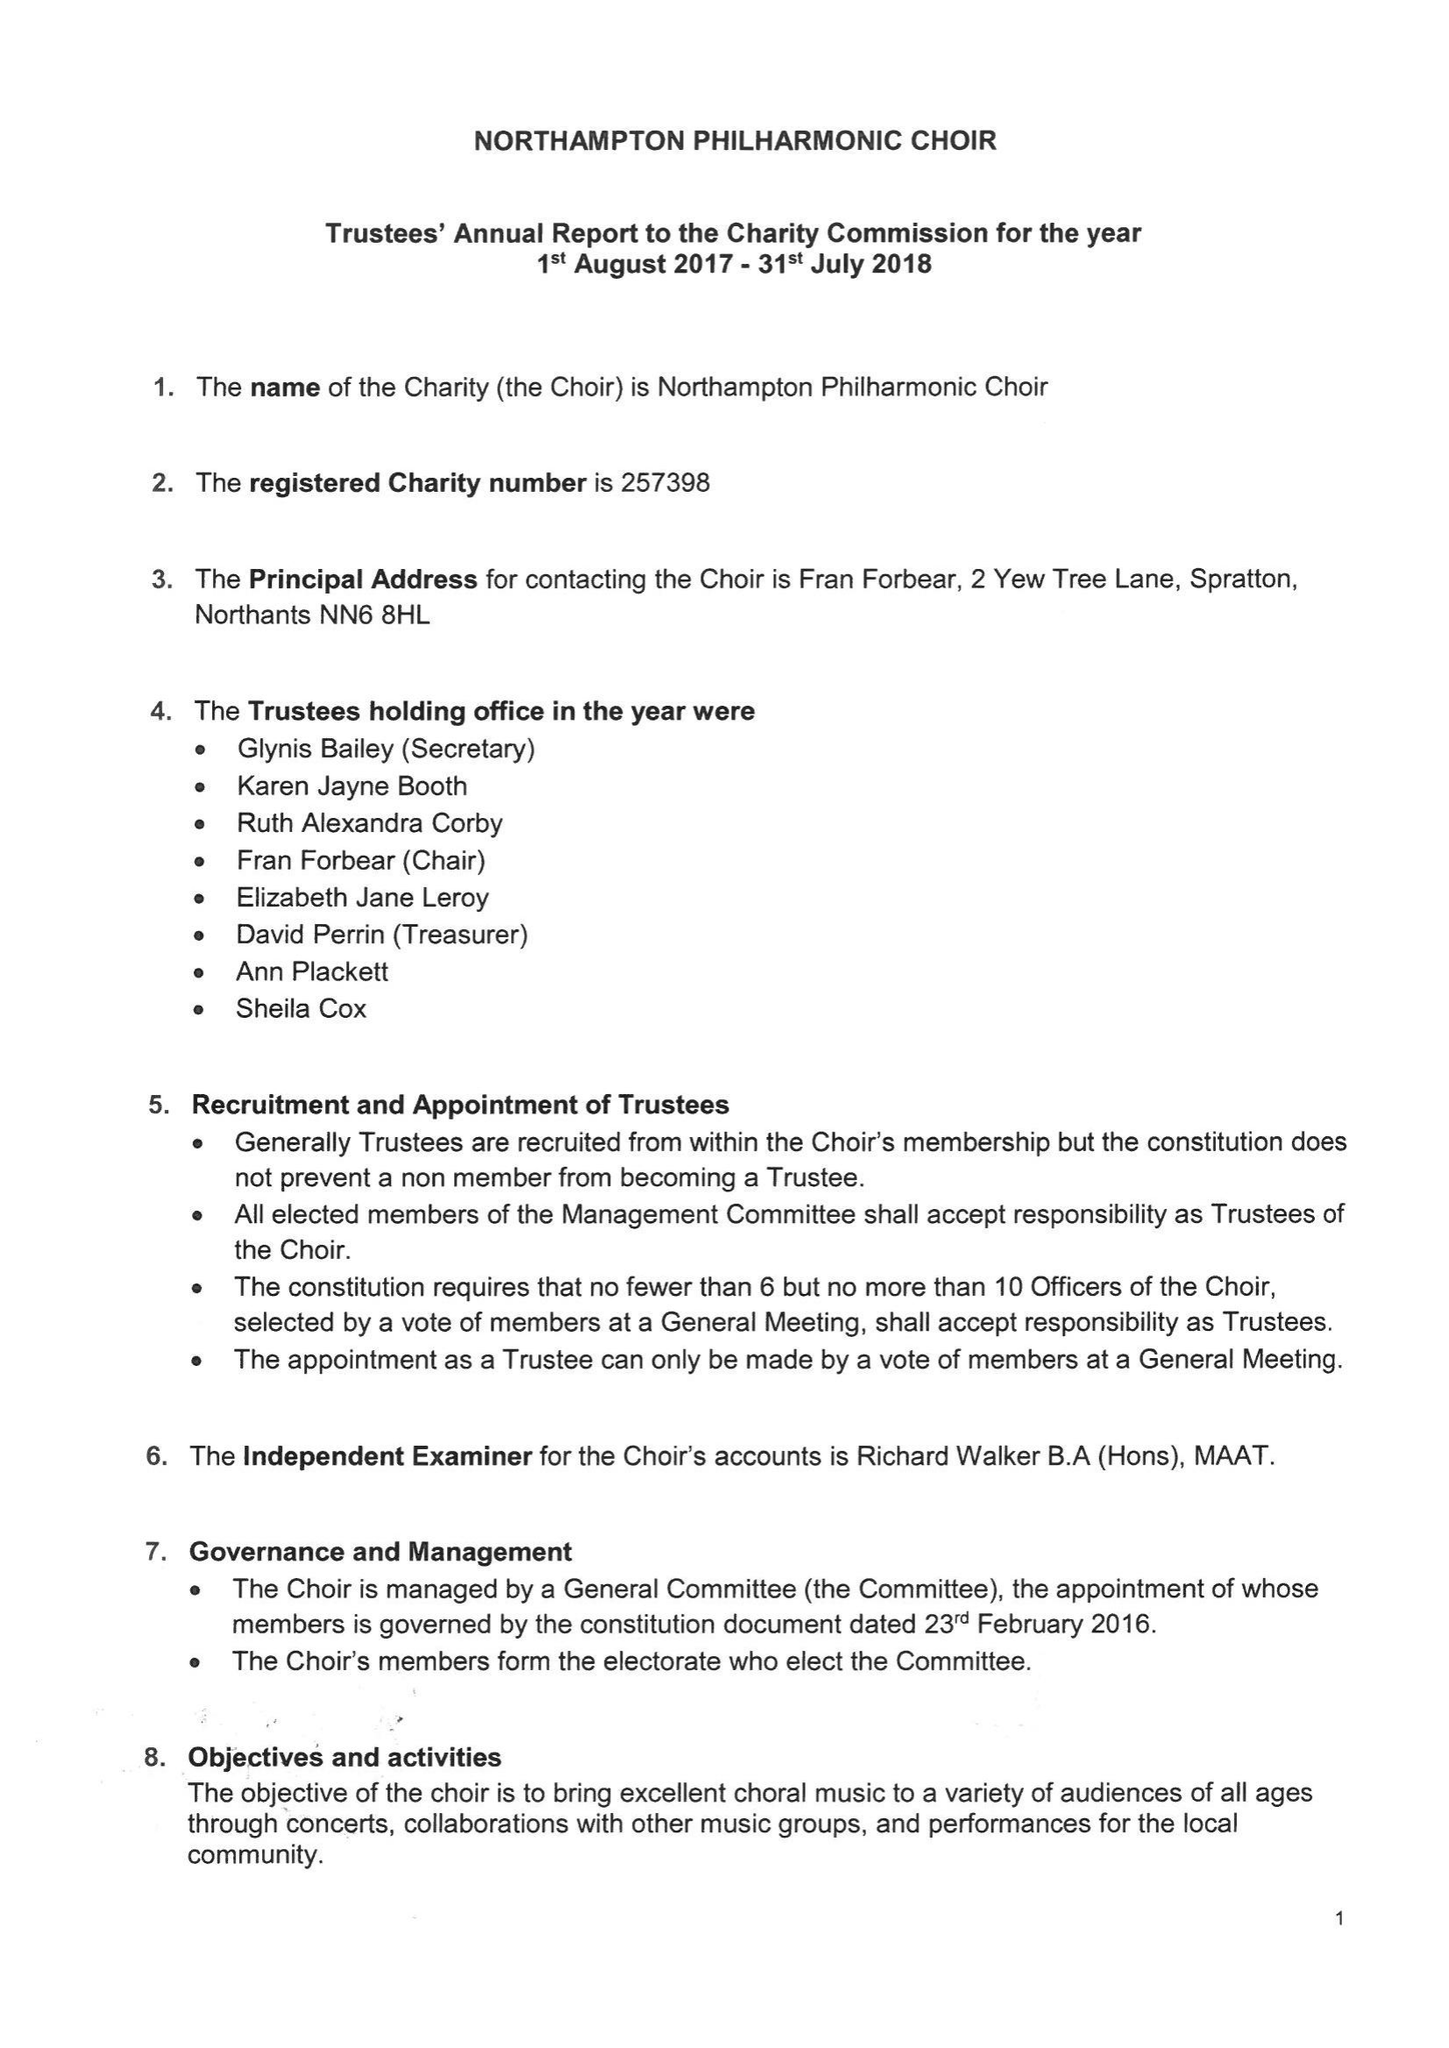What is the value for the report_date?
Answer the question using a single word or phrase. 2018-07-31 